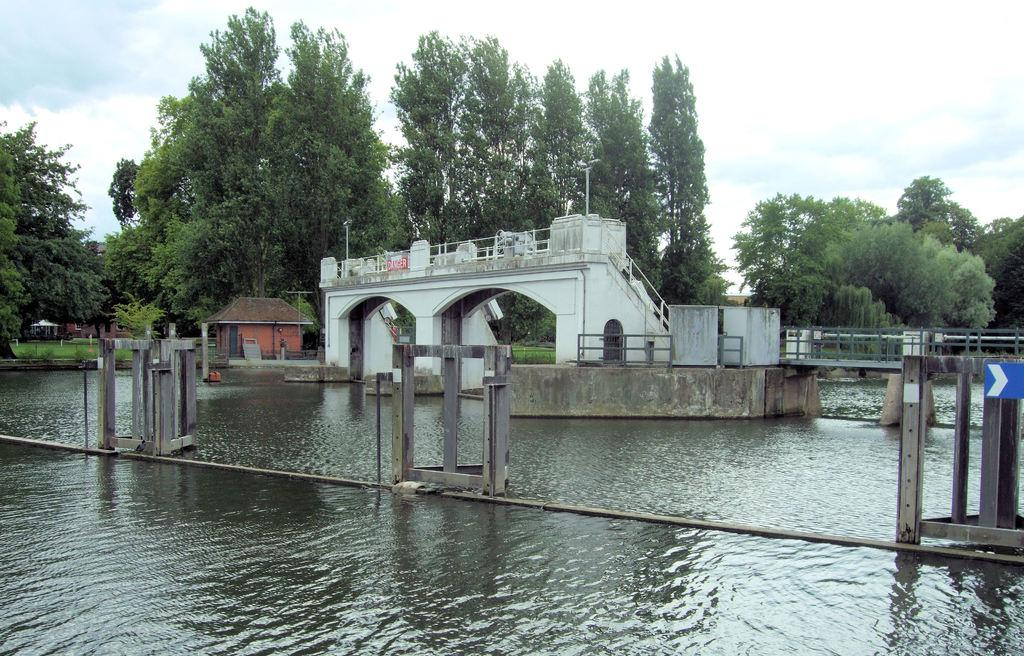What is the primary element visible in the image? There is water in the image. What structure can be seen crossing over the water? There is a bridge in the image. What type of objects are present near the water? There are poles in the image. What type of vegetation is visible in the image? There is grass and trees in the image. What type of buildings can be seen in the image? There are houses in the image. What is visible in the background of the image? The sky is visible in the background of the image, and there are clouds in the sky. What type of voyage is the cloud embarking on in the image? Clouds do not embark on voyages, as they are not living beings or objects capable of movement in the way described. 